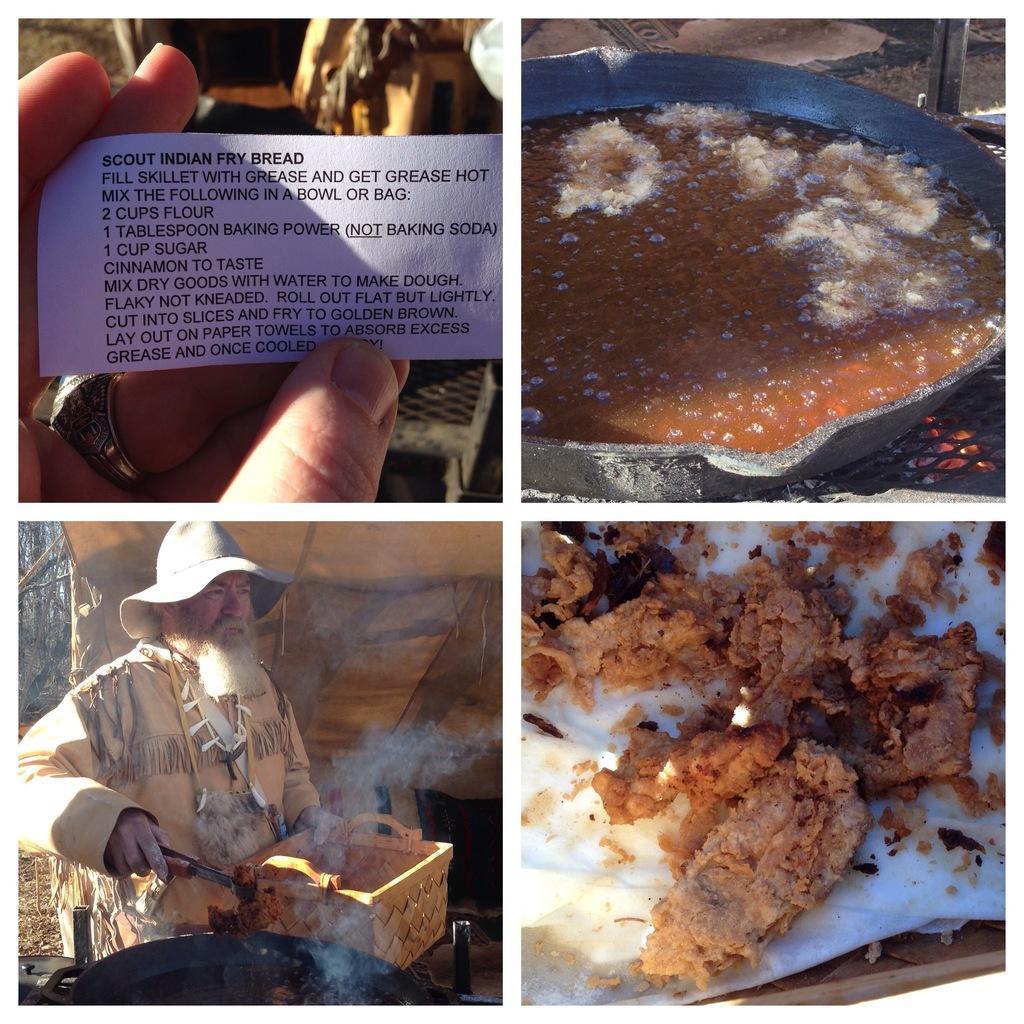In one or two sentences, can you explain what this image depicts? This is a collage of four image. First image a person is holding a paper with something written on it. On the second image there is a vessel with some food item on that. And it is on a grill. On the third image a person is wearing a cap and holding something. In front of him there is a basket. On the fourth image there is a food item on tissue. 